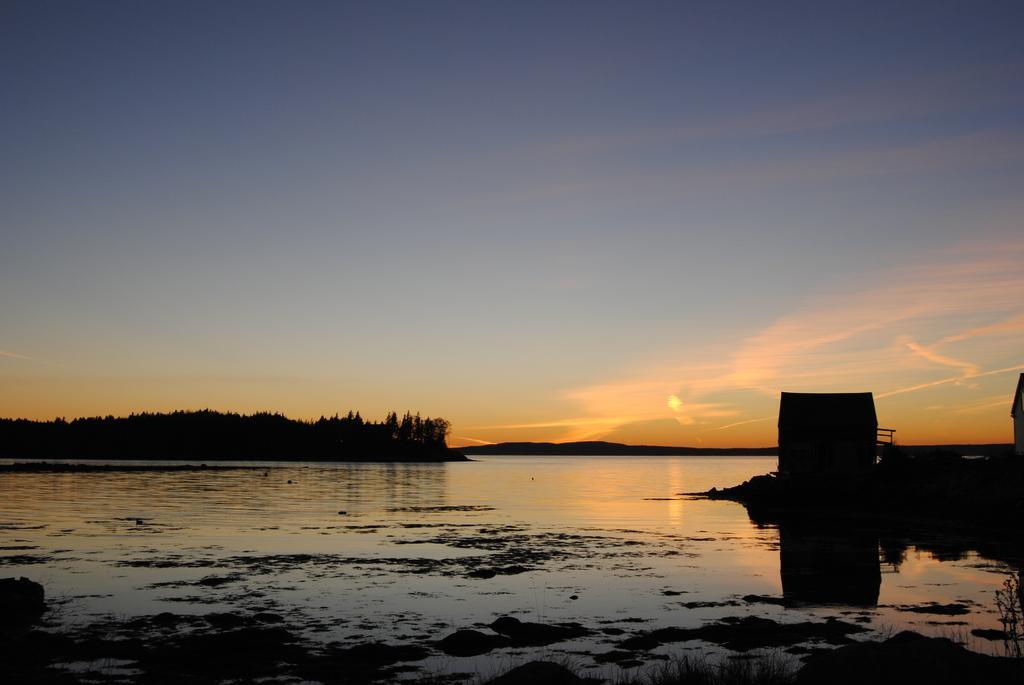Describe this image in one or two sentences. In this picture I can see water, trees and sun in the sky and looks like a house on the right side of the picture and I can see a small room. 